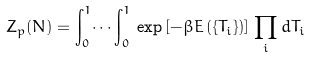<formula> <loc_0><loc_0><loc_500><loc_500>Z _ { p } ( N ) = \int _ { 0 } ^ { 1 } \dots \int _ { 0 } ^ { 1 } \, \exp \left [ - \beta E \left ( \{ T _ { i } \} \right ) \right ] \, \prod _ { i } d T _ { i }</formula> 